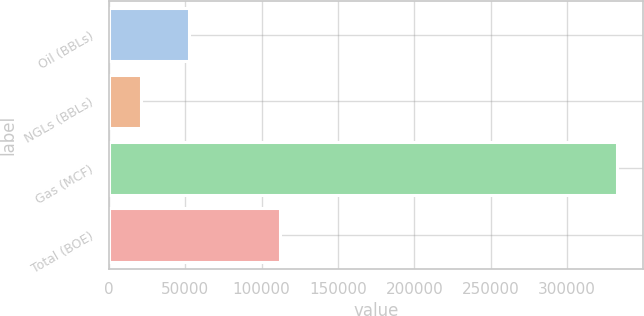Convert chart to OTSL. <chart><loc_0><loc_0><loc_500><loc_500><bar_chart><fcel>Oil (BBLs)<fcel>NGLs (BBLs)<fcel>Gas (MCF)<fcel>Total (BOE)<nl><fcel>52293.7<fcel>21119<fcel>332866<fcel>112184<nl></chart> 